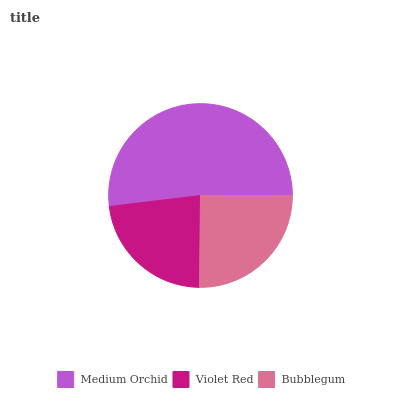Is Violet Red the minimum?
Answer yes or no. Yes. Is Medium Orchid the maximum?
Answer yes or no. Yes. Is Bubblegum the minimum?
Answer yes or no. No. Is Bubblegum the maximum?
Answer yes or no. No. Is Bubblegum greater than Violet Red?
Answer yes or no. Yes. Is Violet Red less than Bubblegum?
Answer yes or no. Yes. Is Violet Red greater than Bubblegum?
Answer yes or no. No. Is Bubblegum less than Violet Red?
Answer yes or no. No. Is Bubblegum the high median?
Answer yes or no. Yes. Is Bubblegum the low median?
Answer yes or no. Yes. Is Violet Red the high median?
Answer yes or no. No. Is Violet Red the low median?
Answer yes or no. No. 